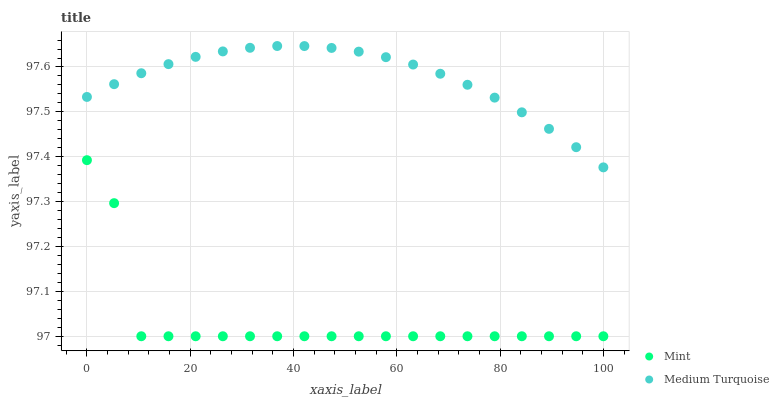Does Mint have the minimum area under the curve?
Answer yes or no. Yes. Does Medium Turquoise have the maximum area under the curve?
Answer yes or no. Yes. Does Medium Turquoise have the minimum area under the curve?
Answer yes or no. No. Is Medium Turquoise the smoothest?
Answer yes or no. Yes. Is Mint the roughest?
Answer yes or no. Yes. Is Medium Turquoise the roughest?
Answer yes or no. No. Does Mint have the lowest value?
Answer yes or no. Yes. Does Medium Turquoise have the lowest value?
Answer yes or no. No. Does Medium Turquoise have the highest value?
Answer yes or no. Yes. Is Mint less than Medium Turquoise?
Answer yes or no. Yes. Is Medium Turquoise greater than Mint?
Answer yes or no. Yes. Does Mint intersect Medium Turquoise?
Answer yes or no. No. 